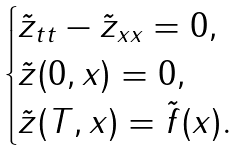Convert formula to latex. <formula><loc_0><loc_0><loc_500><loc_500>\begin{cases} \tilde { z } _ { t t } - \tilde { z } _ { x x } = 0 , \\ \tilde { z } ( 0 , x ) = 0 , \\ \tilde { z } ( T , x ) = \tilde { f } ( x ) . \end{cases}</formula> 